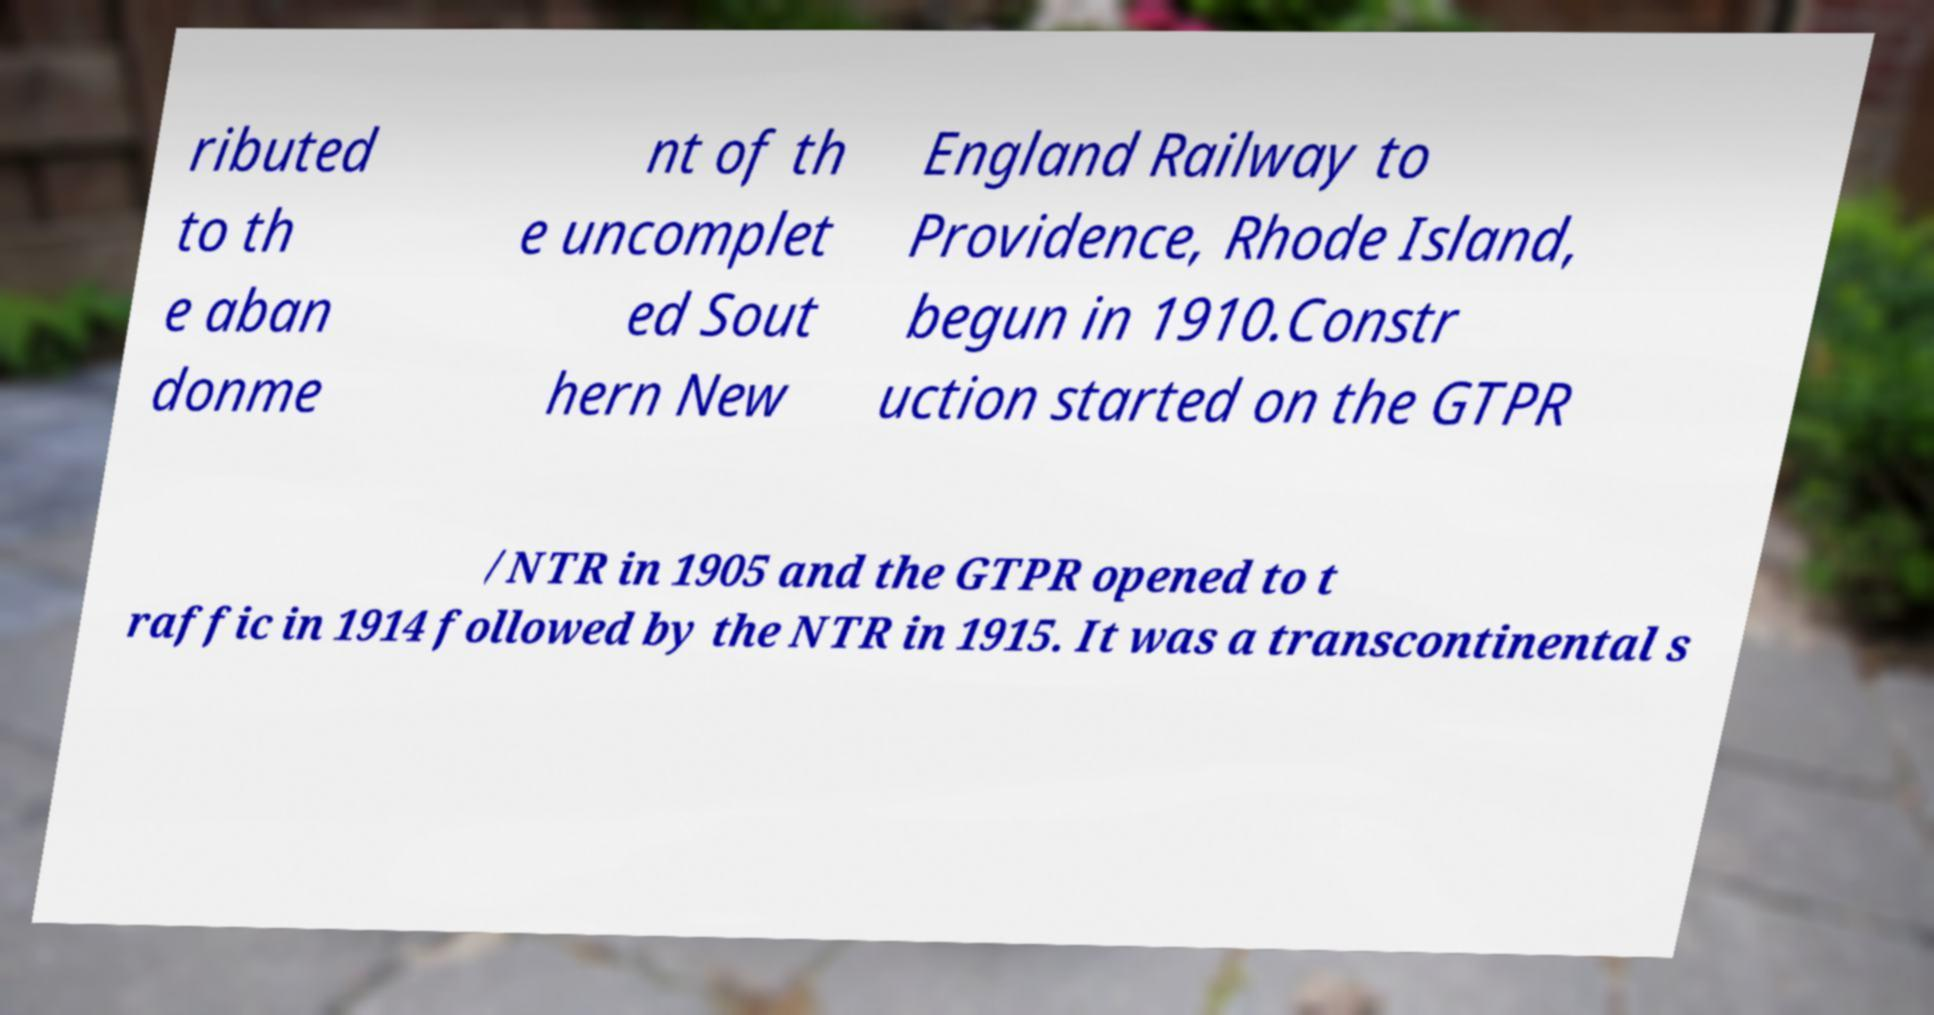What messages or text are displayed in this image? I need them in a readable, typed format. ributed to th e aban donme nt of th e uncomplet ed Sout hern New England Railway to Providence, Rhode Island, begun in 1910.Constr uction started on the GTPR /NTR in 1905 and the GTPR opened to t raffic in 1914 followed by the NTR in 1915. It was a transcontinental s 